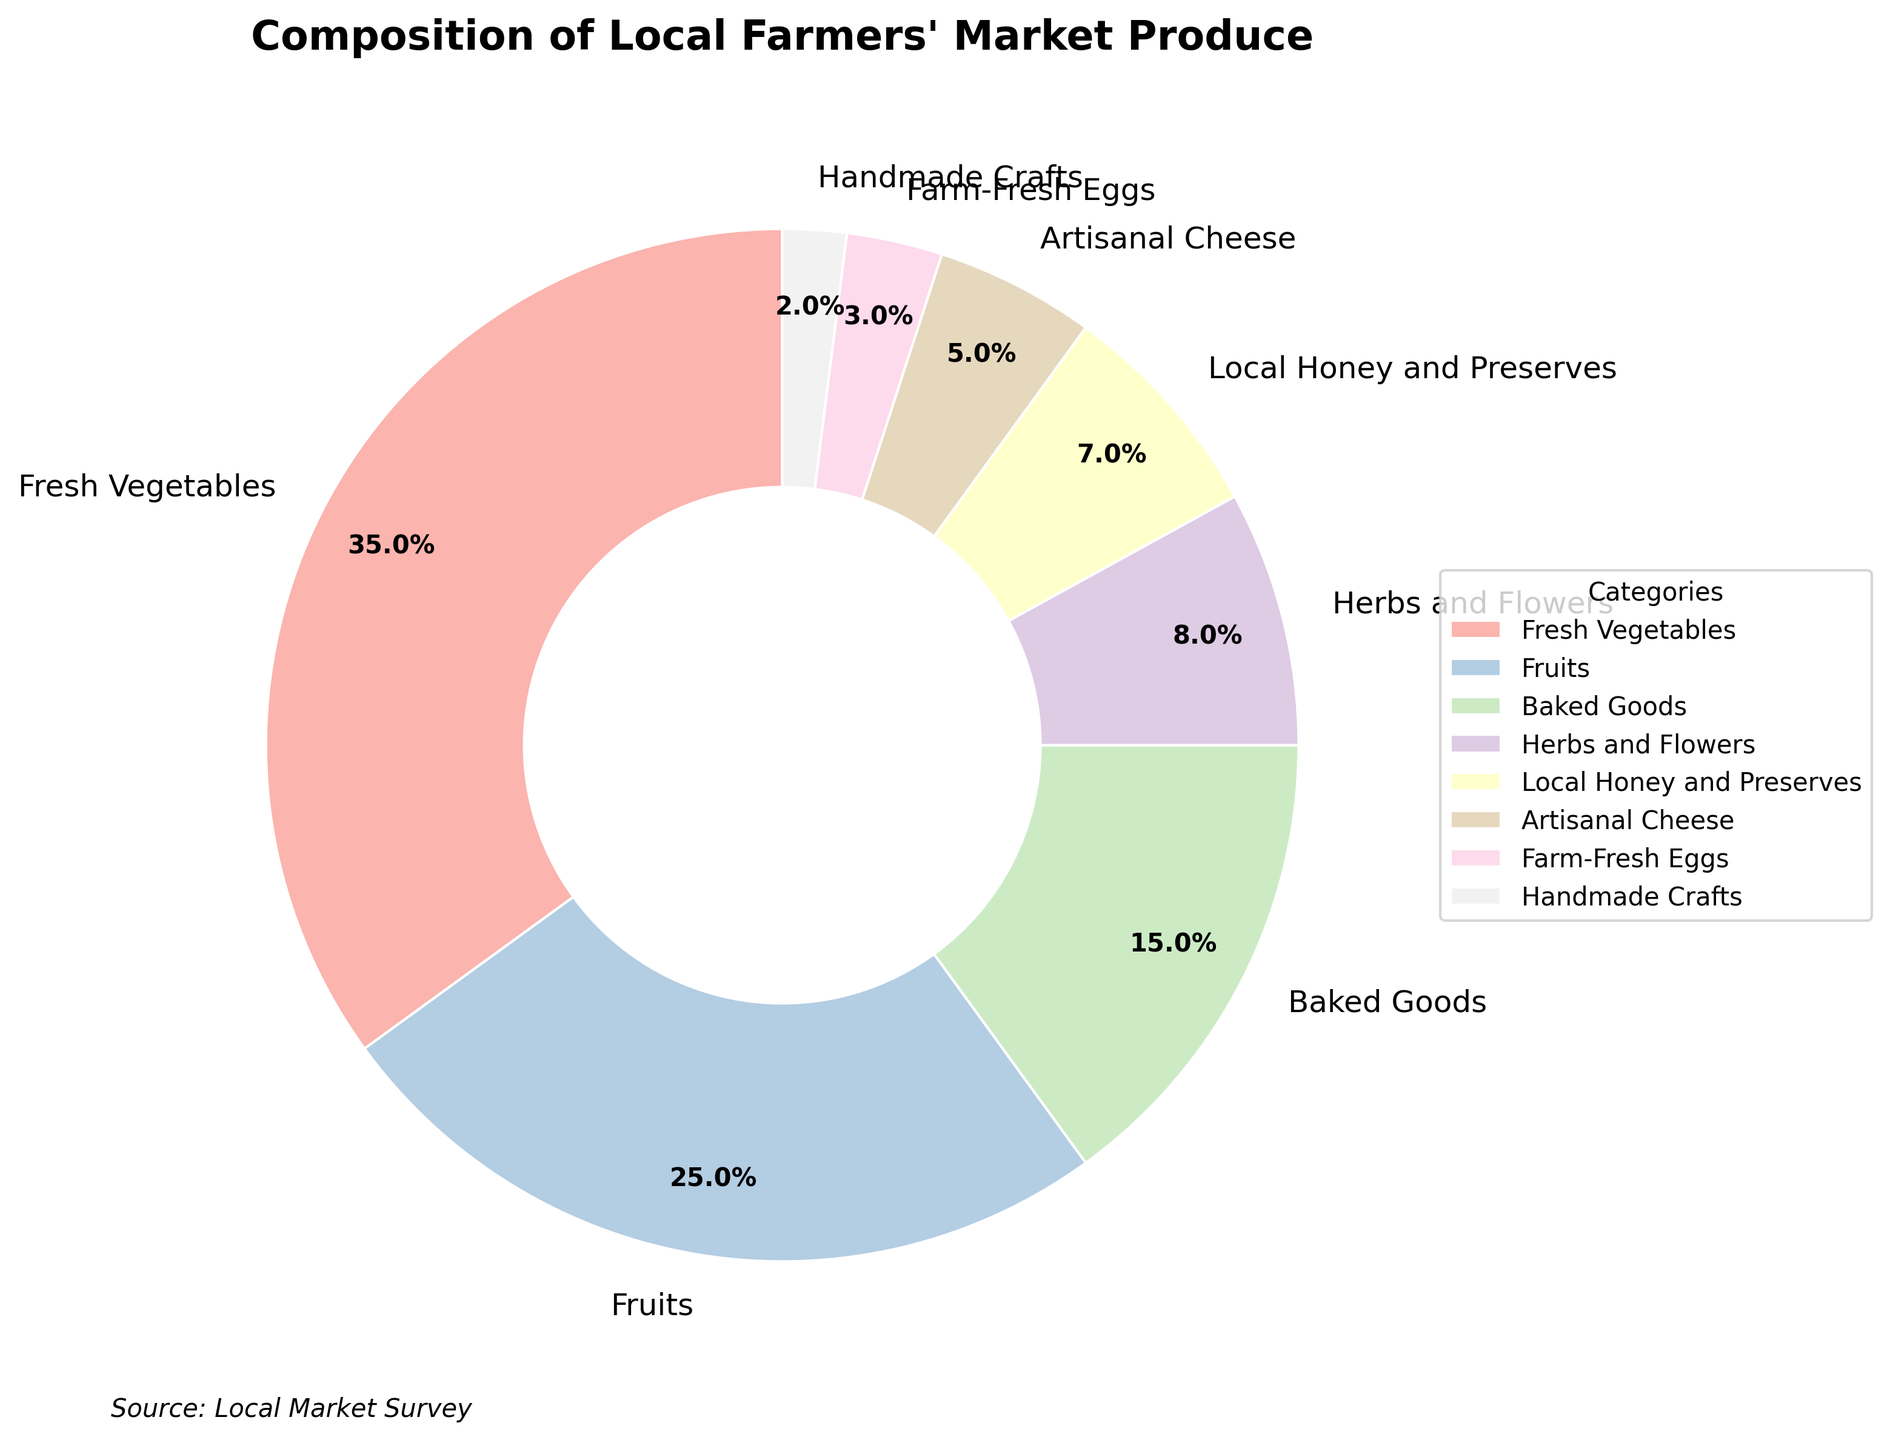what percentage of the market's produce do Fresh Vegetables and Fruits together contribute? Fresh Vegetables contribute 35%, and Fruits contribute 25%. Adding these together, 35% + 25% = 60%.
Answer: 60% Which category occupies a larger share, Baked Goods or Herbs and Flowers? Baked Goods make up 15%, while Herbs and Flowers make up 8%. Since 15% is greater than 8%, Baked Goods occupy a larger share.
Answer: Baked Goods How much more significant is the percentage of Fresh Vegetables compared to Farm-Fresh Eggs? Fresh Vegetables account for 35%, and Farm-Fresh Eggs account for 3%. The difference is 35% - 3% = 32%.
Answer: 32% What three categories, when combined, make up the majority of the produce at the market? Fresh Vegetables (35%), Fruits (25%), and Baked Goods (15%) combined account for 35% + 25% + 15% = 75%, which is more than half of the total.
Answer: Fresh Vegetables, Fruits, and Baked Goods What is the total percentage contribution of categories that make up less than 10% of the market each? The categories are Herbs and Flowers (8%), Local Honey and Preserves (7%), Artisanal Cheese (5%), Farm-Fresh Eggs (3%), and Handmade Crafts (2%). Summing them: 8% + 7% + 5% + 3% + 2% = 25%.
Answer: 25% Which category has the smallest representation at the market? Handmade Crafts represents 2%, which is the smallest percentage among the categories listed.
Answer: Handmade Crafts How does the percentage of Fruits compare to that of Local Honey and Preserves? Fruits account for 25%, while Local Honey and Preserves account for 7%. Therefore, Fruits are represented more significantly.
Answer: Fruits are more significant By how much is the proportion of Baked Goods greater than that of Artisanal Cheese? Baked Goods contribute 15%, and Artisanal Cheese contributes 5%. The difference is 15% - 5% = 10%.
Answer: 10% If you sum up the percentages of Artisanal Cheese, Farm-Fresh Eggs, and Handmade Crafts, what is their total contribution? Artisanal Cheese is 5%, Farm-Fresh Eggs are 3%, and Handmade Crafts are 2%. The total is 5% + 3% + 2% = 10%.
Answer: 10% Given the visual layout of the pie chart, which category utilizes the bright pink color segment? The visual layout assigns the bright pink color to the Fresh Vegetables segment, making it visually stand out.
Answer: Fresh Vegetables 